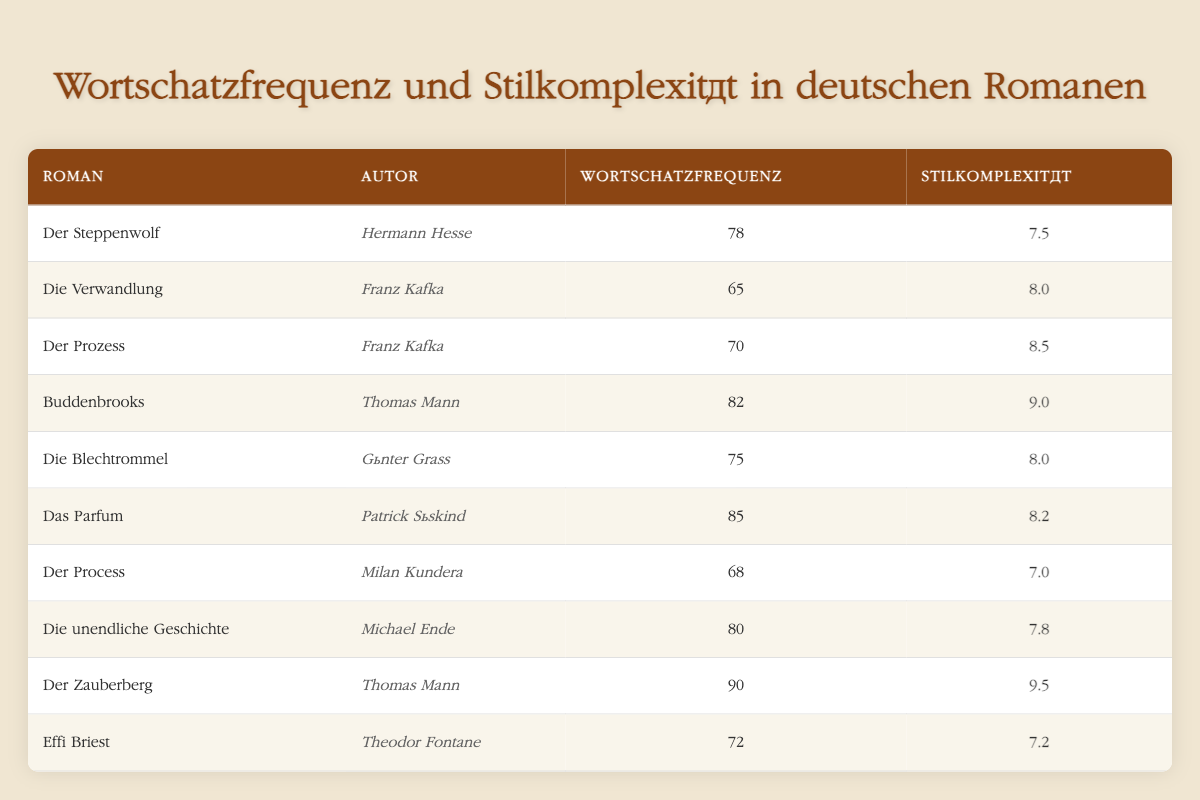What is the vocabulary frequency of "Der Zauberberg"? From the table, "Der Zauberberg" has a listed vocabulary frequency of 90.
Answer: 90 Who is the author of "Die Verwandlung"? The table shows that "Die Verwandlung" is written by Franz Kafka.
Answer: Franz Kafka Which novel has the highest writing style complexity? In the table, "Der Zauberberg" has the highest writing style complexity at 9.5.
Answer: Der Zauberberg What is the average vocabulary frequency of the novels by Thomas Mann? The novels by Thomas Mann are "Buddenbrooks" (82) and "Der Zauberberg" (90). Their sum is 82 + 90 = 172. Thus, the average is 172 / 2 = 86.
Answer: 86 Is the vocabulary frequency of "Das Parfum" greater than that of "Die Blechtrommel"? "Das Parfum" has a vocabulary frequency of 85, while "Die Blechtrommel" has 75, which means 85 is greater than 75.
Answer: Yes Which author has written novels that have both a vocabulary frequency greater than 80 and a writing style complexity greater than 8? In the table, "Buddenbrooks" by Thomas Mann (82, 9.0) and "Der Zauberberg" (90, 9.5). Both novels meet the criteria of having vocabulary frequency greater than 80 and writing style complexity greater than 8.
Answer: Thomas Mann What is the difference in writing style complexity between "Der Steppenwolf" and "Die unendliche Geschichte"? "Der Steppenwolf" has a complexity of 7.5 and "Die unendliche Geschichte" has 7.8. The difference is 7.8 - 7.5 = 0.3.
Answer: 0.3 How many novels have a writing style complexity of 8 or higher? The novels with a writing style complexity of 8 or higher are "Die Verwandlung" (8.0), "Der Prozess" (8.5), "Buddenbrooks" (9.0), "Das Parfum" (8.2), "Der Zauberberg" (9.5), and "Die Blechtrommel" (8.0) which totals to 6 novels.
Answer: 6 What is the minimum vocabulary frequency among the listed novels? The minimum vocabulary frequency in the table is for "Die Verwandlung" which has a value of 65.
Answer: 65 